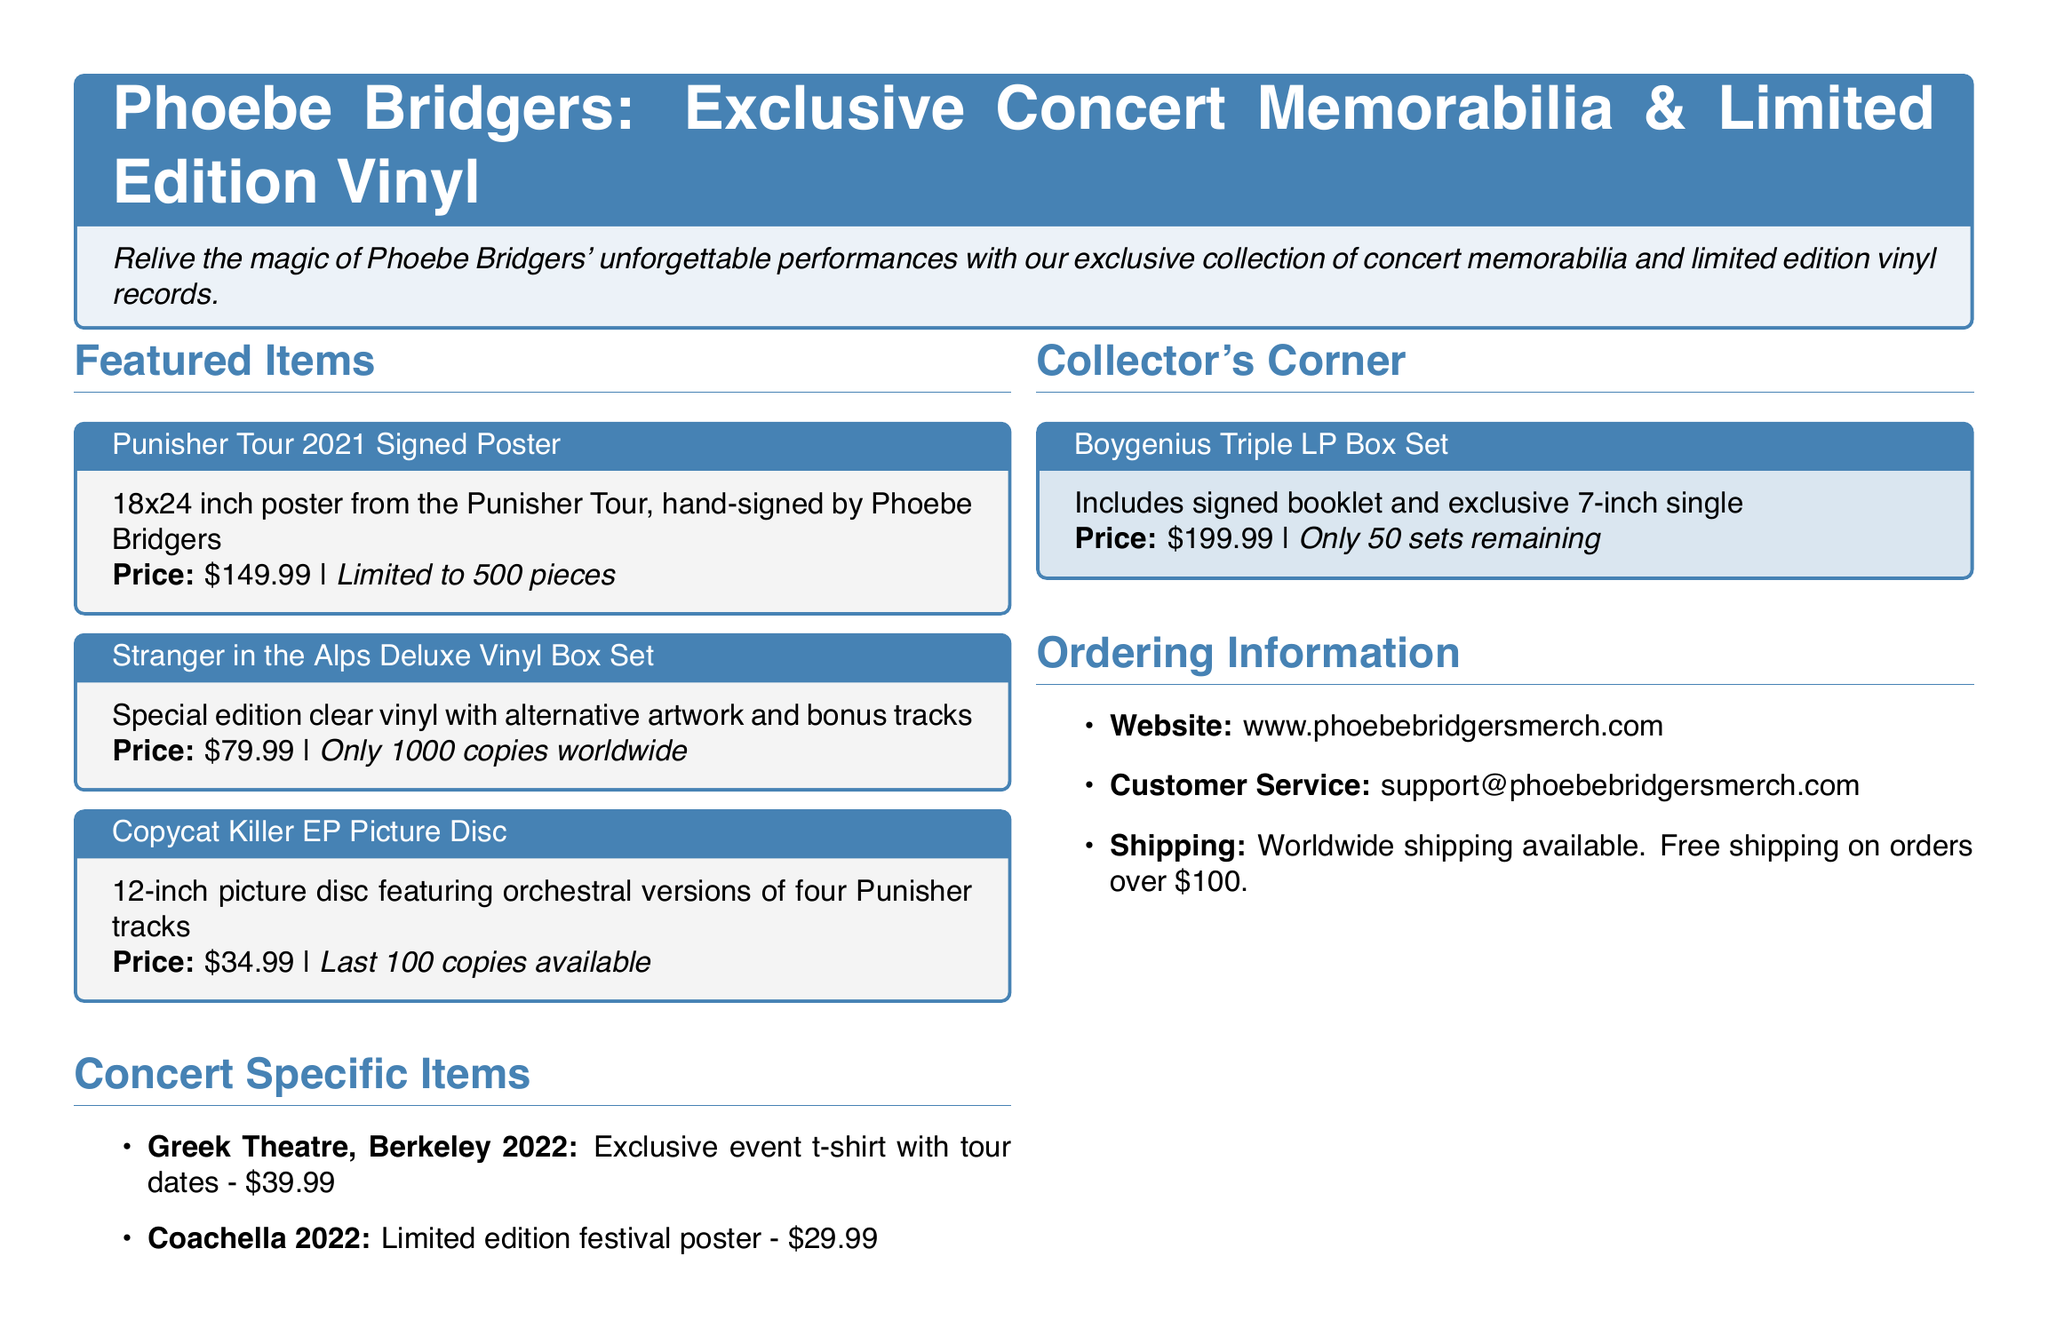What is the price of the Punisher Tour signed poster? The document lists the price of the poster as $149.99.
Answer: $149.99 How many copies of the Stranger in the Alps Deluxe Vinyl Box Set are available? The document states that there are only 1000 copies worldwide.
Answer: 1000 copies What is the size of the Copycat Killer EP Picture Disc? The document specifies that the picture disc is 12-inch.
Answer: 12-inch What is the price of the exclusive event t-shirt from the Greek Theatre performance in 2022? The t-shirt's price is indicated as $39.99.
Answer: $39.99 How many sets of the Boygenius Triple LP Box Set are remaining? The document states that there are only 50 sets remaining.
Answer: 50 sets What are the items listed under "Concert Specific Items"? The document lists two items: an exclusive event t-shirt and a limited edition festival poster.
Answer: Exclusive event t-shirt, limited edition festival poster What is the email address for customer service? The document provides the email address as support@phoebebridgersmerch.com.
Answer: support@phoebebridgersmerch.com Is free shipping available on orders over a certain amount? The document states free shipping is available on orders over $100.
Answer: Yes, over $100 